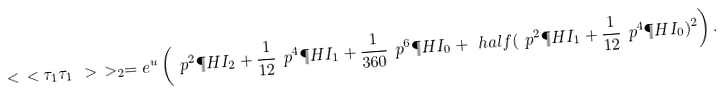Convert formula to latex. <formula><loc_0><loc_0><loc_500><loc_500>\ < \ < \tau _ { 1 } \tau _ { 1 } \ > \ > _ { 2 } = e ^ { u } \left ( \ p ^ { 2 } \P H I _ { 2 } + \frac { 1 } { 1 2 } \ p ^ { 4 } \P H I _ { 1 } + \frac { 1 } { 3 6 0 } \ p ^ { 6 } \P H I _ { 0 } + \ h a l f ( \ p ^ { 2 } \P H I _ { 1 } + \frac { 1 } { 1 2 } \ p ^ { 4 } \P H I _ { 0 } ) ^ { 2 } \right ) .</formula> 